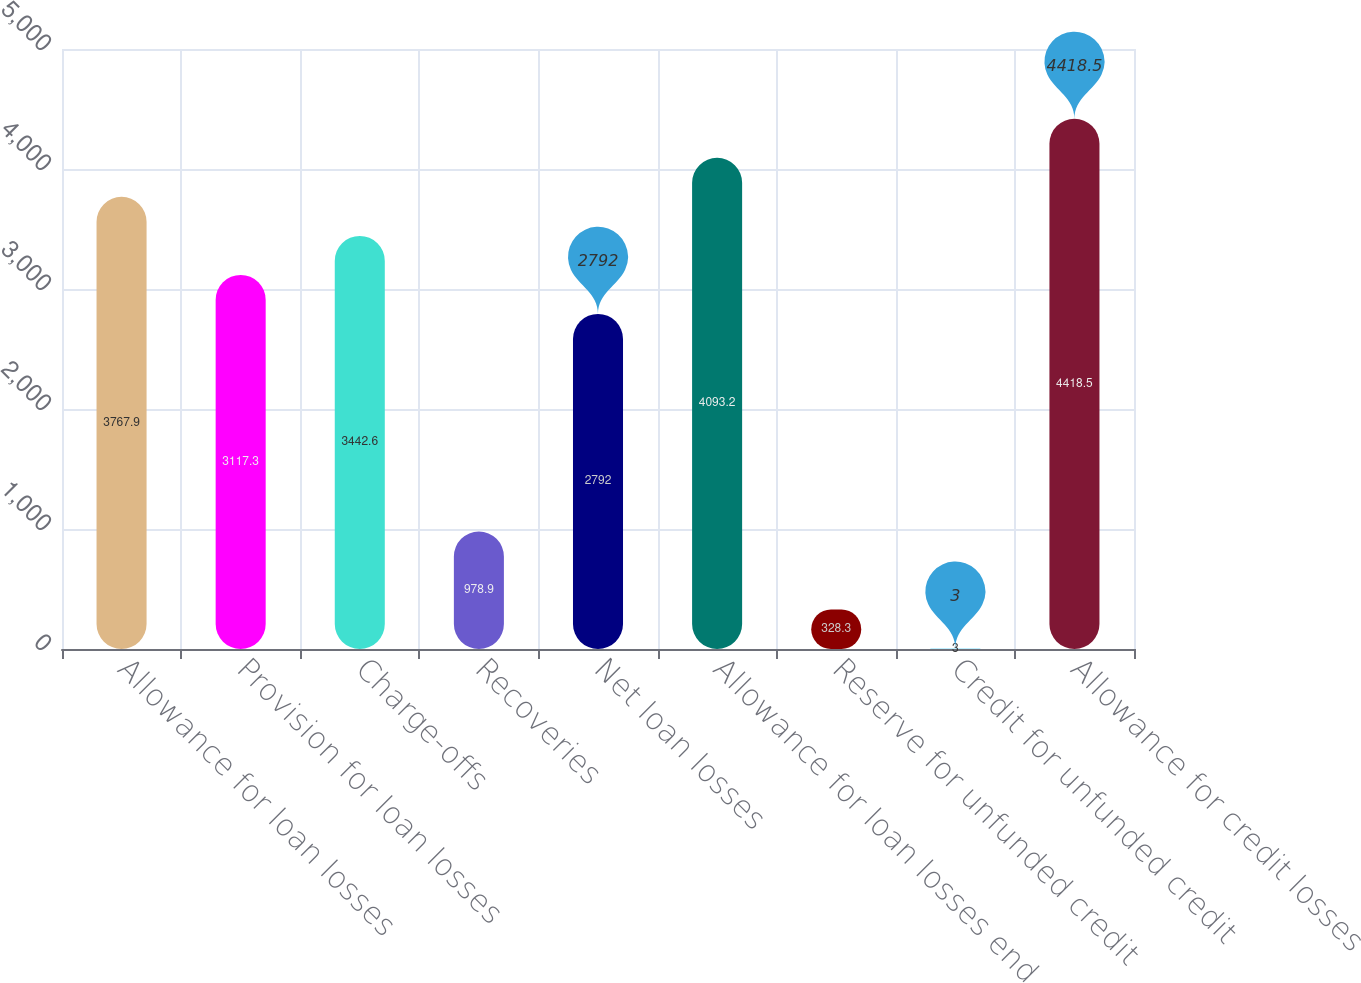<chart> <loc_0><loc_0><loc_500><loc_500><bar_chart><fcel>Allowance for loan losses<fcel>Provision for loan losses<fcel>Charge-offs<fcel>Recoveries<fcel>Net loan losses<fcel>Allowance for loan losses end<fcel>Reserve for unfunded credit<fcel>Credit for unfunded credit<fcel>Allowance for credit losses<nl><fcel>3767.9<fcel>3117.3<fcel>3442.6<fcel>978.9<fcel>2792<fcel>4093.2<fcel>328.3<fcel>3<fcel>4418.5<nl></chart> 